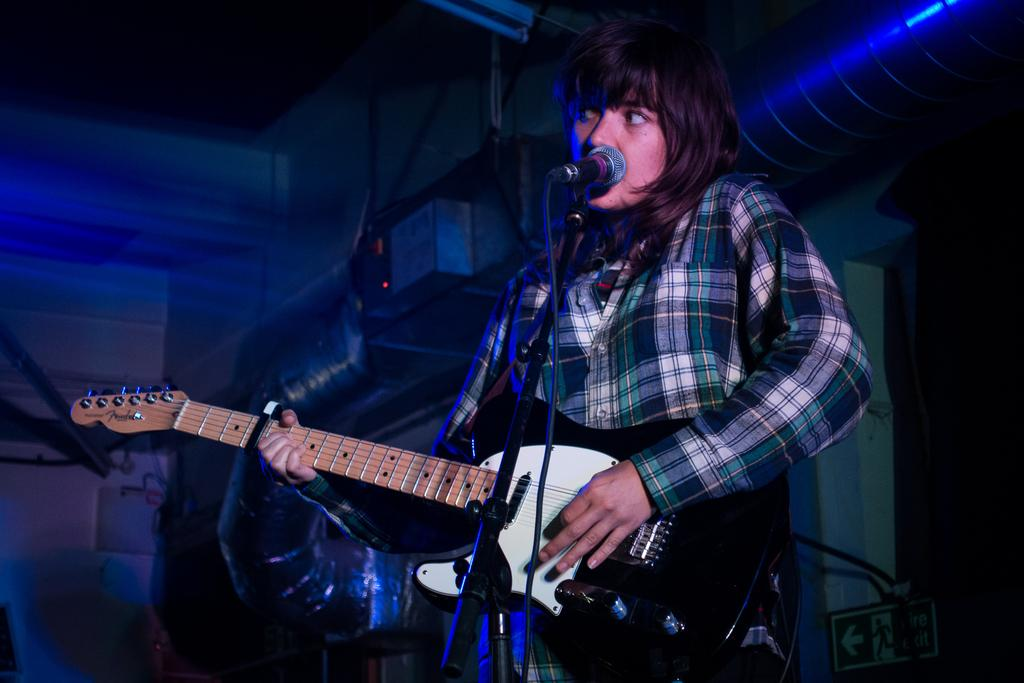What is the main subject of the image? The main subject of the image is a woman. What is the woman doing in the image? The woman is singing a song and playing a guitar. What object is present in the image that might be used for amplifying her voice? There is a microphone in the image. Where is the nest located in the image? There is no nest present in the image. What type of shelf can be seen in the image? There is no shelf present in the image. Can you tell me where the hydrant is in the image? There is no hydrant present in the image. 